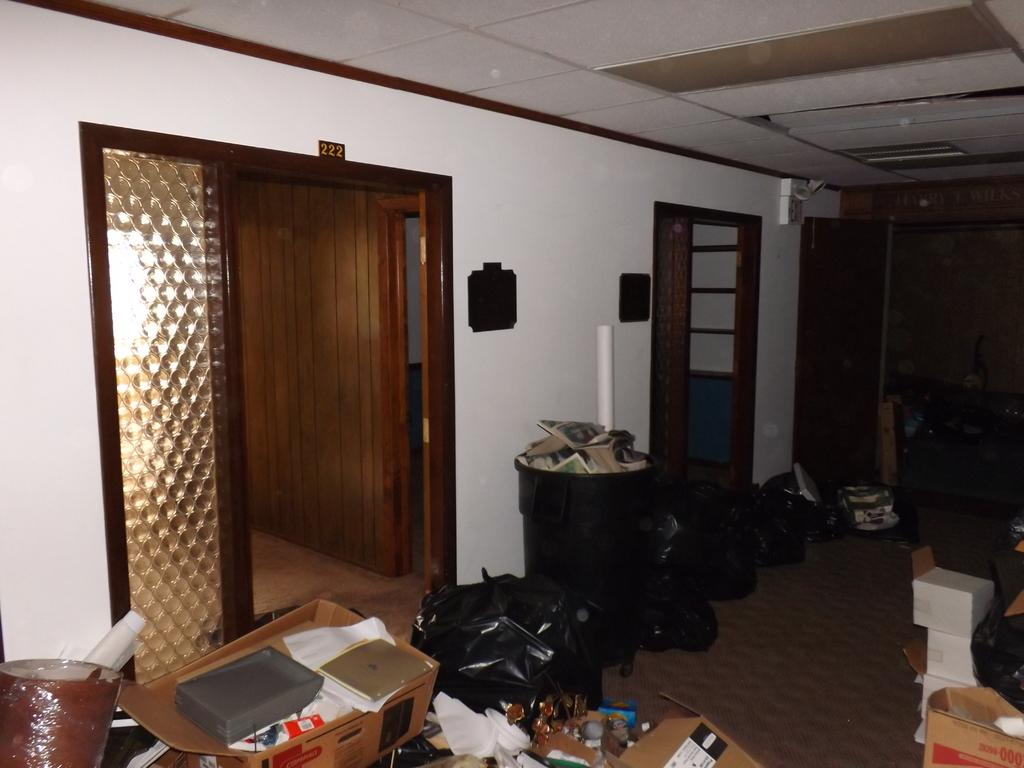What part of the room can be seen in the image? The ceiling is visible in the image. What type of items are present in the image? There are boxes and objects in the image. What is the purpose of the number board in the image? The number board in the image is likely used for counting or organizing items. What material is the wall made of in the image? The wall in the image is made of wood. What are the black covers used for in the image? The black covers in the image might be used for covering or protecting objects. What part of the floor can be seen in the image? The floor is visible in the image. What type of vegetable is being written about by the writer in the image? There is no writer or vegetable present in the image. What type of cannon is visible in the image? There is no cannon present in the image. 